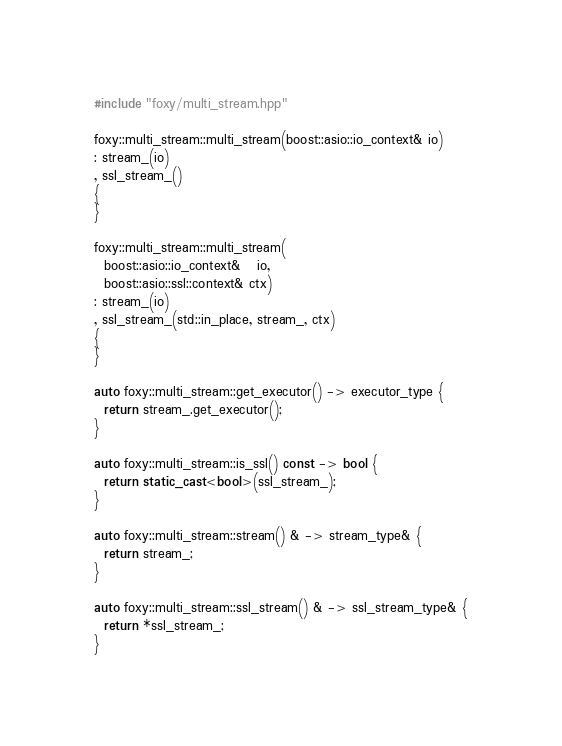Convert code to text. <code><loc_0><loc_0><loc_500><loc_500><_C++_>#include "foxy/multi_stream.hpp"

foxy::multi_stream::multi_stream(boost::asio::io_context& io)
: stream_(io)
, ssl_stream_()
{
}

foxy::multi_stream::multi_stream(
  boost::asio::io_context&   io,
  boost::asio::ssl::context& ctx)
: stream_(io)
, ssl_stream_(std::in_place, stream_, ctx)
{
}

auto foxy::multi_stream::get_executor() -> executor_type {
  return stream_.get_executor();
}

auto foxy::multi_stream::is_ssl() const -> bool {
  return static_cast<bool>(ssl_stream_);
}

auto foxy::multi_stream::stream() & -> stream_type& {
  return stream_;
}

auto foxy::multi_stream::ssl_stream() & -> ssl_stream_type& {
  return *ssl_stream_;
}</code> 